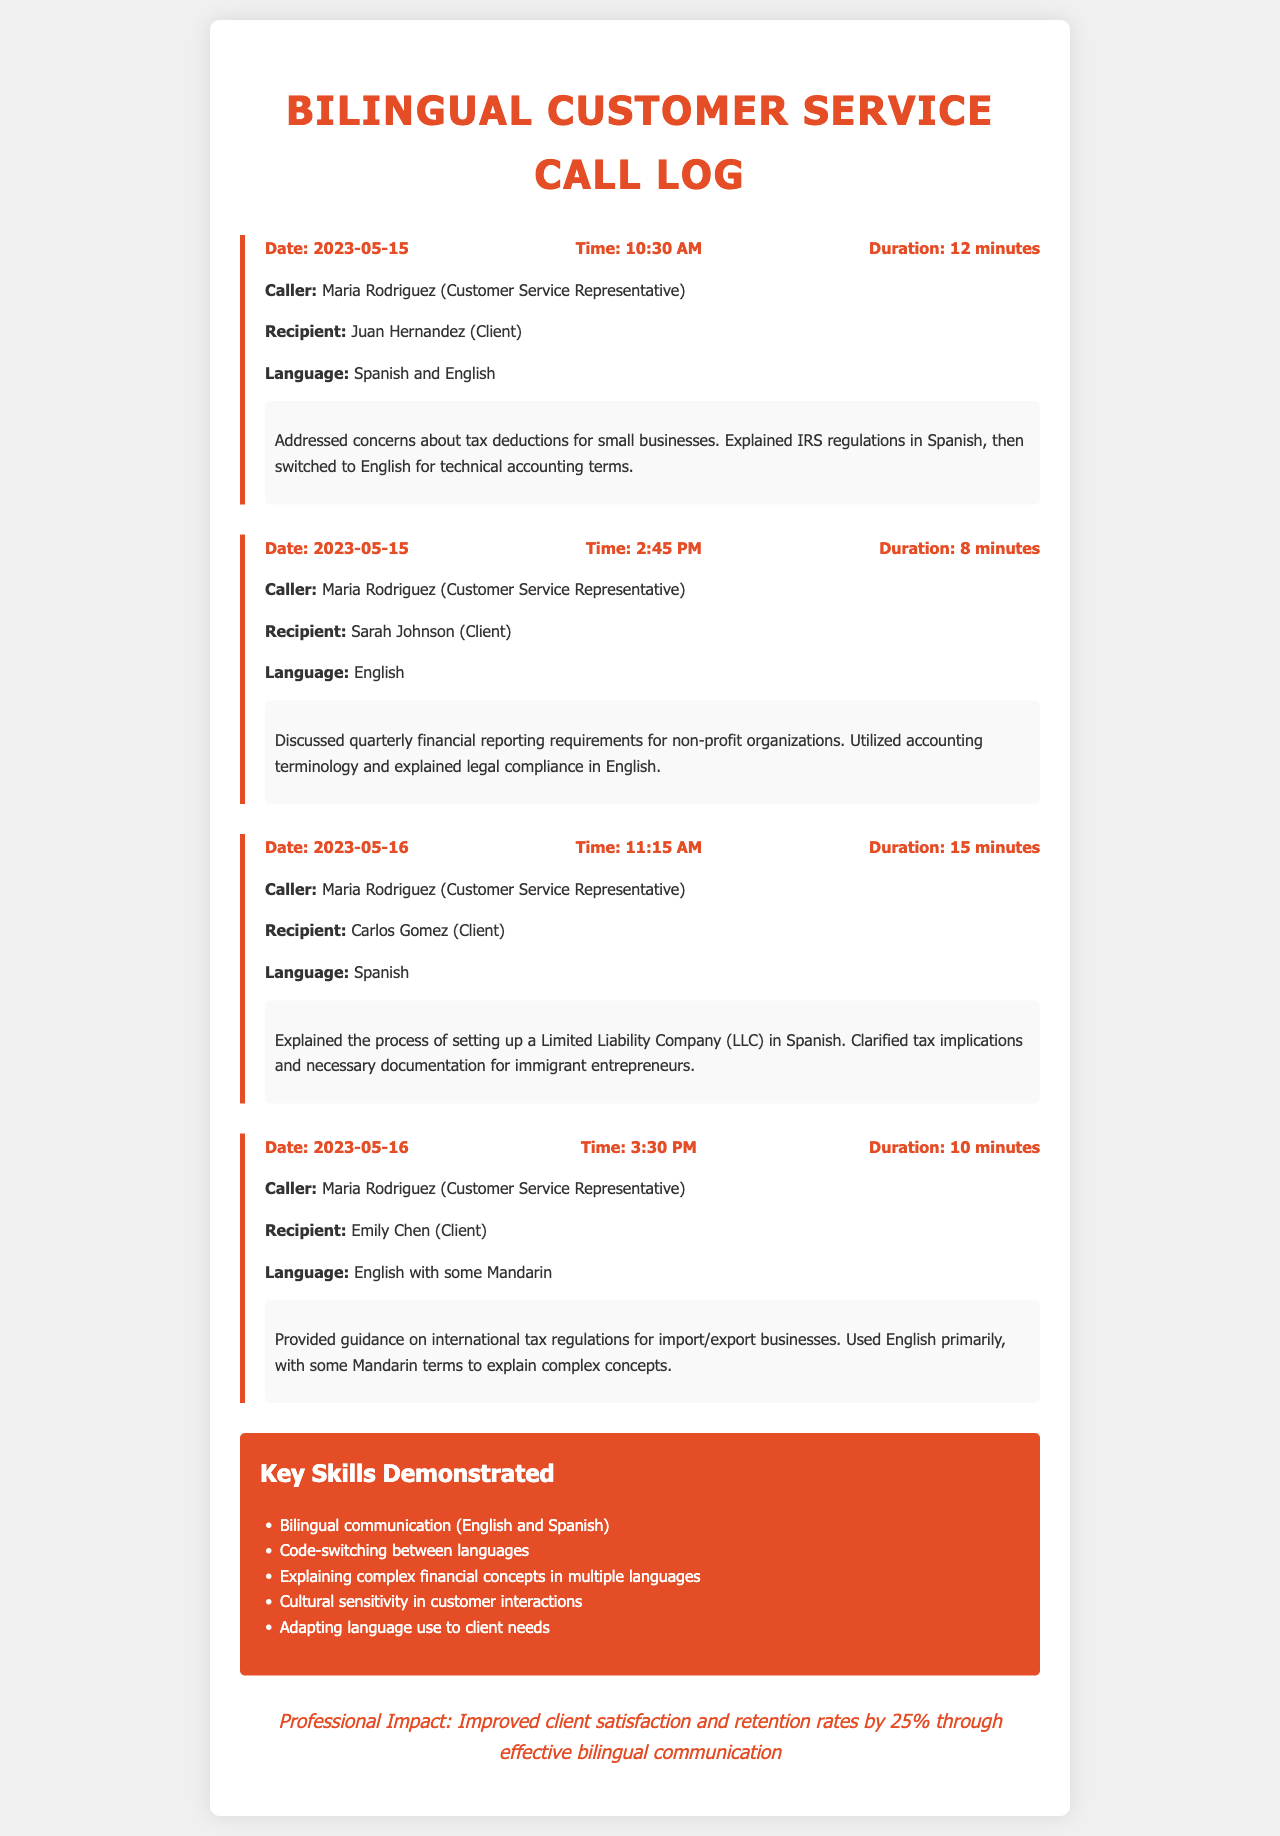What is the duration of the call with Juan Hernandez? The duration is listed in the call log for the interaction with Juan Hernandez, which is 12 minutes.
Answer: 12 minutes What language was primarily used in the call with Carlos Gomez? The document specifies that Spanish was the language used during the call with Carlos Gomez.
Answer: Spanish On what date did Maria Rodriguez discuss quarterly financial reporting requirements? The call log indicates that this discussion took place on 2023-05-15.
Answer: 2023-05-15 Which client did Maria Rodriguez speak to at 3:30 PM? The document mentions that the recipient of the call at this time was Emily Chen.
Answer: Emily Chen What skills were demonstrated by Maria Rodriguez? The skills listed in the document include bilingual communication and code-switching among others.
Answer: Bilingual communication How many minutes did the call with Sarah Johnson last? The duration of the call is stated in the records, which confirms it lasted 8 minutes.
Answer: 8 minutes What type of business did Maria Rodriguez provide guidance for during the call with Emily Chen? The call log shows that guidance was provided for international tax regulations related to import/export businesses.
Answer: Import/export businesses What was the impact of effective bilingual communication as noted in the document? The professional impact section states that it improved client satisfaction and retention rates by 25%.
Answer: 25% 